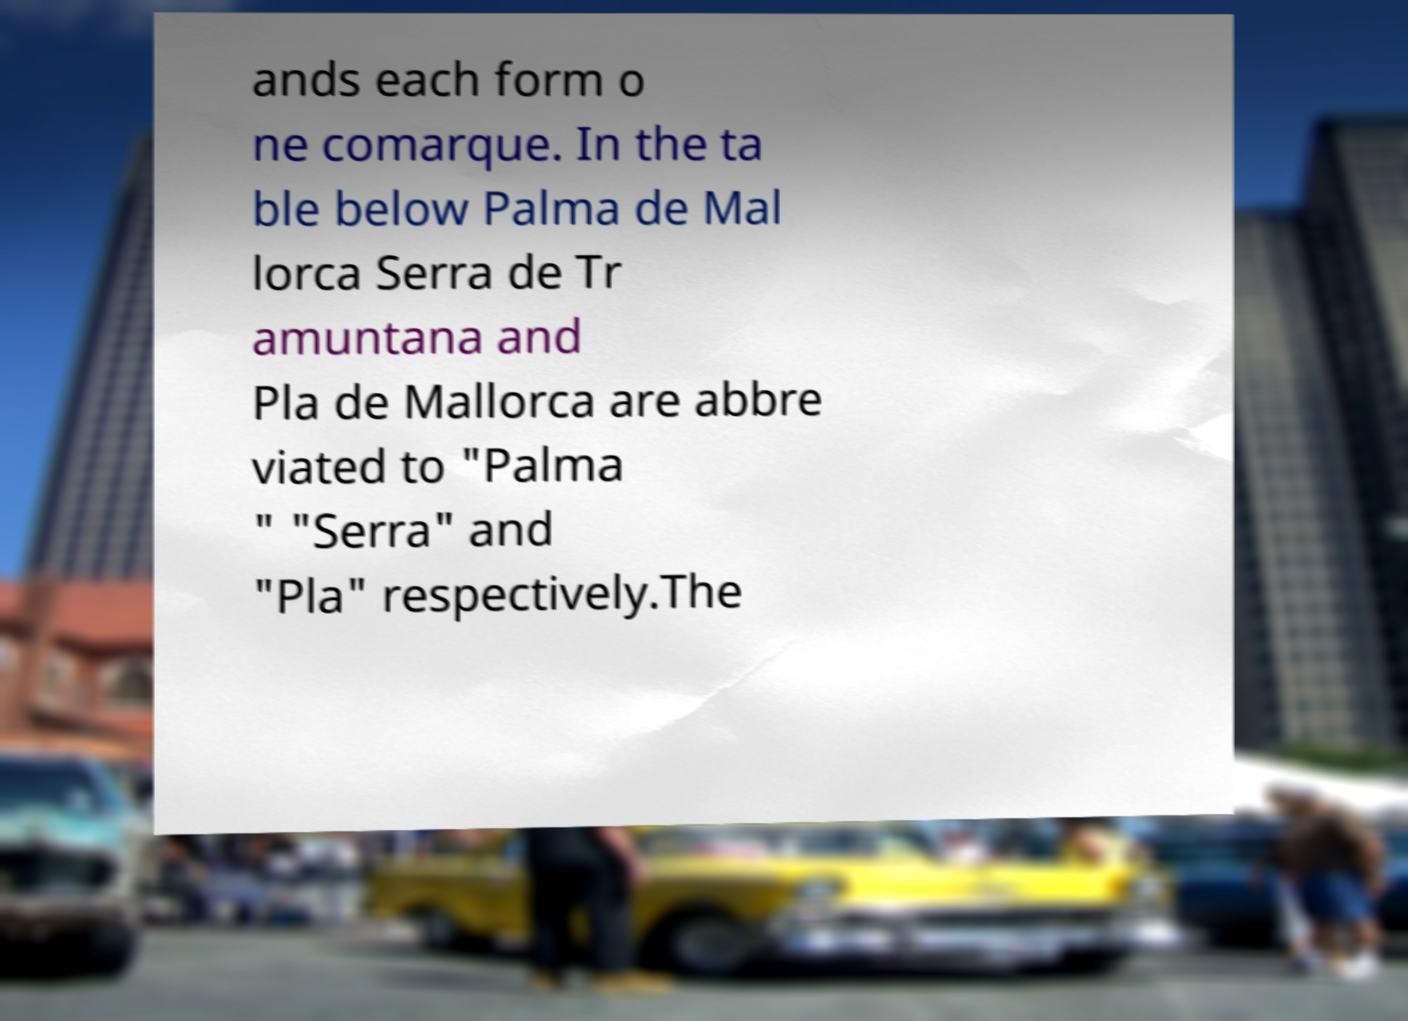There's text embedded in this image that I need extracted. Can you transcribe it verbatim? ands each form o ne comarque. In the ta ble below Palma de Mal lorca Serra de Tr amuntana and Pla de Mallorca are abbre viated to "Palma " "Serra" and "Pla" respectively.The 